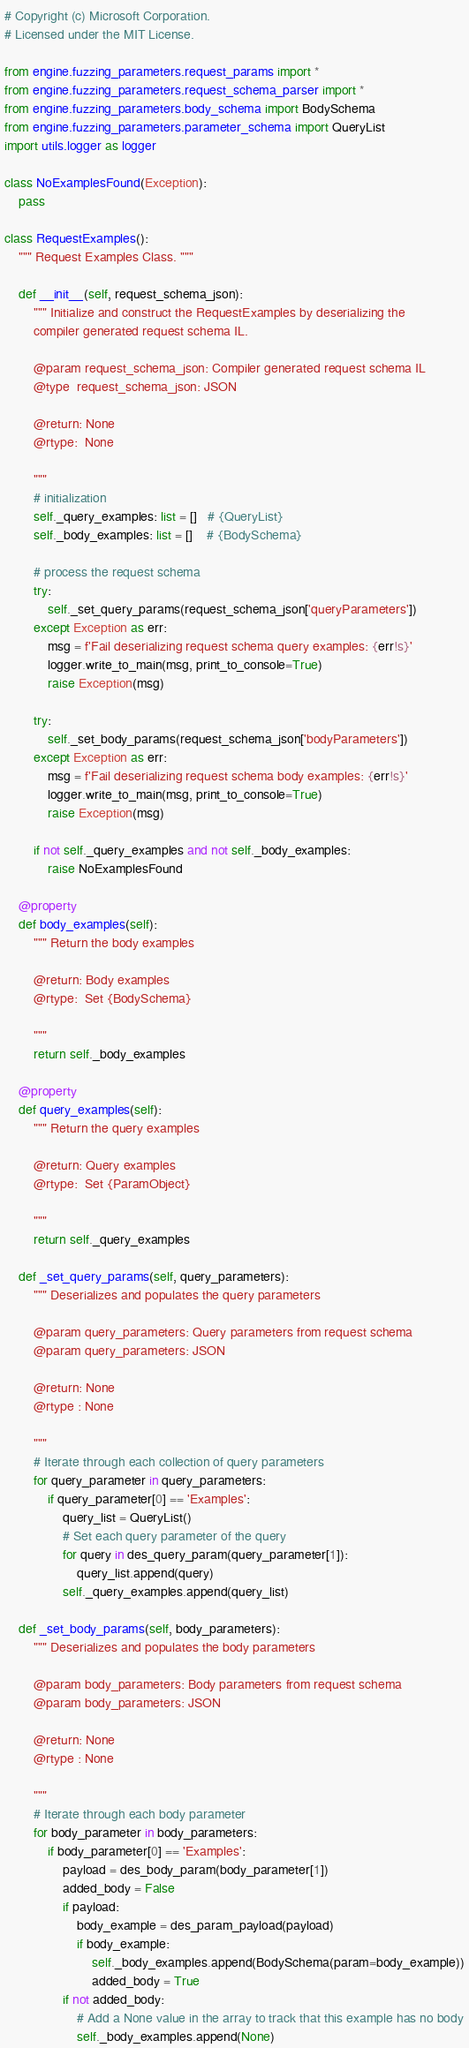<code> <loc_0><loc_0><loc_500><loc_500><_Python_># Copyright (c) Microsoft Corporation.
# Licensed under the MIT License.

from engine.fuzzing_parameters.request_params import *
from engine.fuzzing_parameters.request_schema_parser import *
from engine.fuzzing_parameters.body_schema import BodySchema
from engine.fuzzing_parameters.parameter_schema import QueryList
import utils.logger as logger

class NoExamplesFound(Exception):
    pass

class RequestExamples():
    """ Request Examples Class. """

    def __init__(self, request_schema_json):
        """ Initialize and construct the RequestExamples by deserializing the
        compiler generated request schema IL.

        @param request_schema_json: Compiler generated request schema IL
        @type  request_schema_json: JSON

        @return: None
        @rtype:  None

        """
        # initialization
        self._query_examples: list = []   # {QueryList}
        self._body_examples: list = []    # {BodySchema}

        # process the request schema
        try:
            self._set_query_params(request_schema_json['queryParameters'])
        except Exception as err:
            msg = f'Fail deserializing request schema query examples: {err!s}'
            logger.write_to_main(msg, print_to_console=True)
            raise Exception(msg)

        try:
            self._set_body_params(request_schema_json['bodyParameters'])
        except Exception as err:
            msg = f'Fail deserializing request schema body examples: {err!s}'
            logger.write_to_main(msg, print_to_console=True)
            raise Exception(msg)

        if not self._query_examples and not self._body_examples:
            raise NoExamplesFound

    @property
    def body_examples(self):
        """ Return the body examples

        @return: Body examples
        @rtype:  Set {BodySchema}

        """
        return self._body_examples

    @property
    def query_examples(self):
        """ Return the query examples

        @return: Query examples
        @rtype:  Set {ParamObject}

        """
        return self._query_examples

    def _set_query_params(self, query_parameters):
        """ Deserializes and populates the query parameters

        @param query_parameters: Query parameters from request schema
        @param query_parameters: JSON

        @return: None
        @rtype : None

        """
        # Iterate through each collection of query parameters
        for query_parameter in query_parameters:
            if query_parameter[0] == 'Examples':
                query_list = QueryList()
                # Set each query parameter of the query
                for query in des_query_param(query_parameter[1]):
                    query_list.append(query)
                self._query_examples.append(query_list)

    def _set_body_params(self, body_parameters):
        """ Deserializes and populates the body parameters

        @param body_parameters: Body parameters from request schema
        @param body_parameters: JSON

        @return: None
        @rtype : None

        """
        # Iterate through each body parameter
        for body_parameter in body_parameters:
            if body_parameter[0] == 'Examples':
                payload = des_body_param(body_parameter[1])
                added_body = False
                if payload:
                    body_example = des_param_payload(payload)
                    if body_example:
                        self._body_examples.append(BodySchema(param=body_example))
                        added_body = True
                if not added_body:
                    # Add a None value in the array to track that this example has no body
                    self._body_examples.append(None)
</code> 